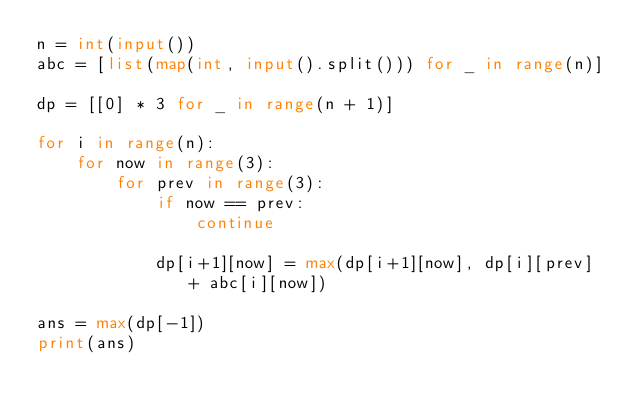Convert code to text. <code><loc_0><loc_0><loc_500><loc_500><_Python_>n = int(input())
abc = [list(map(int, input().split())) for _ in range(n)]

dp = [[0] * 3 for _ in range(n + 1)]

for i in range(n):
    for now in range(3):
        for prev in range(3):
            if now == prev:
                continue

            dp[i+1][now] = max(dp[i+1][now], dp[i][prev] + abc[i][now])

ans = max(dp[-1])
print(ans)
</code> 